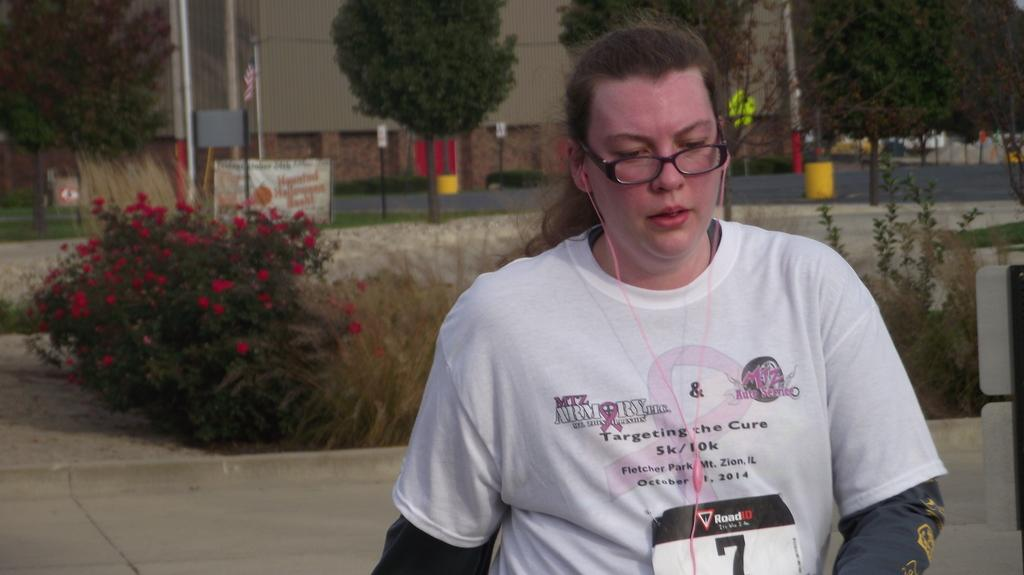Who is present in the image? There is a woman in the image. What is the woman wearing? The woman is wearing a white t-shirt. What is written on the t-shirt? There is text written on the t-shirt. What can be seen in the background of the image? There are plants, trees, and buildings in the background of the image. What type of leather is visible on the woman's shoes in the image? There is no leather visible on the woman's shoes in the image, as the facts provided do not mention any shoes or leather. 